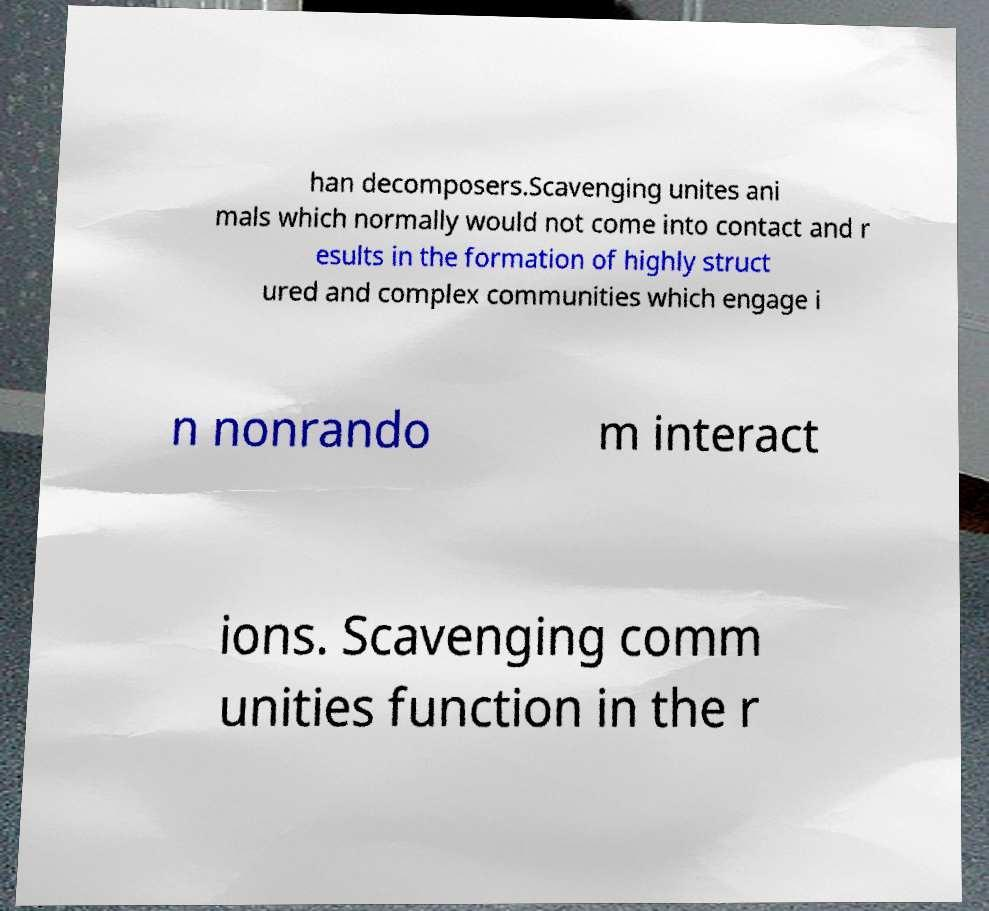For documentation purposes, I need the text within this image transcribed. Could you provide that? han decomposers.Scavenging unites ani mals which normally would not come into contact and r esults in the formation of highly struct ured and complex communities which engage i n nonrando m interact ions. Scavenging comm unities function in the r 